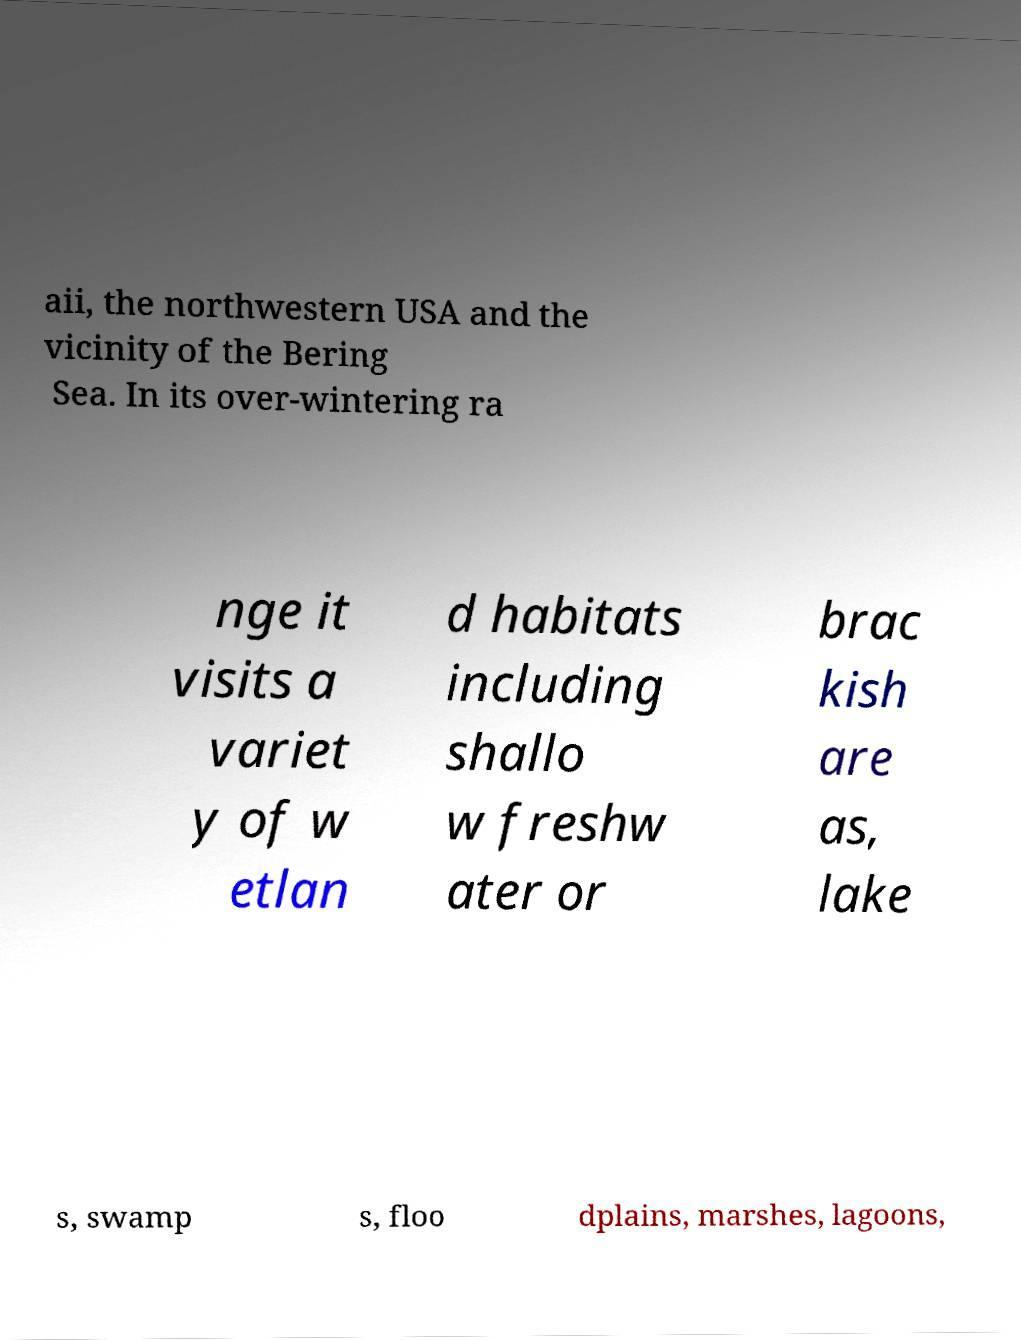Please identify and transcribe the text found in this image. aii, the northwestern USA and the vicinity of the Bering Sea. In its over-wintering ra nge it visits a variet y of w etlan d habitats including shallo w freshw ater or brac kish are as, lake s, swamp s, floo dplains, marshes, lagoons, 